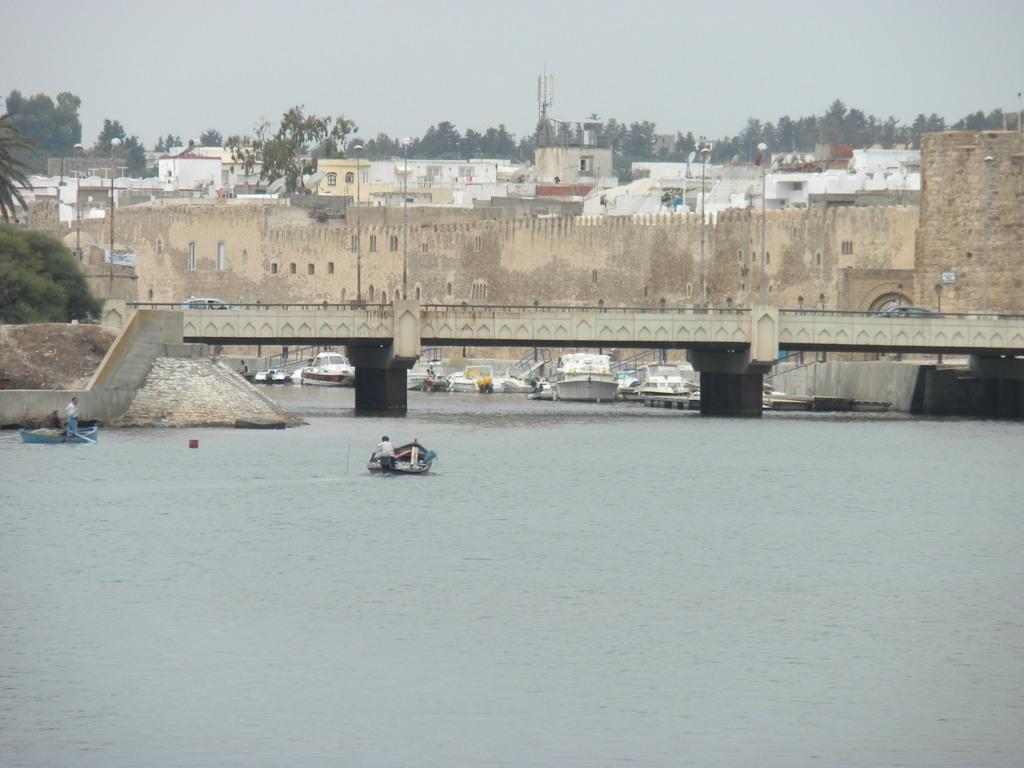How would you summarize this image in a sentence or two? In this image there are some boats parked on the surface of the water and there are also some people sailing the boats. In the background there are two cars present on the bridge. Image also consists of many buildings and also trees and some poles. Sky is at the top. 